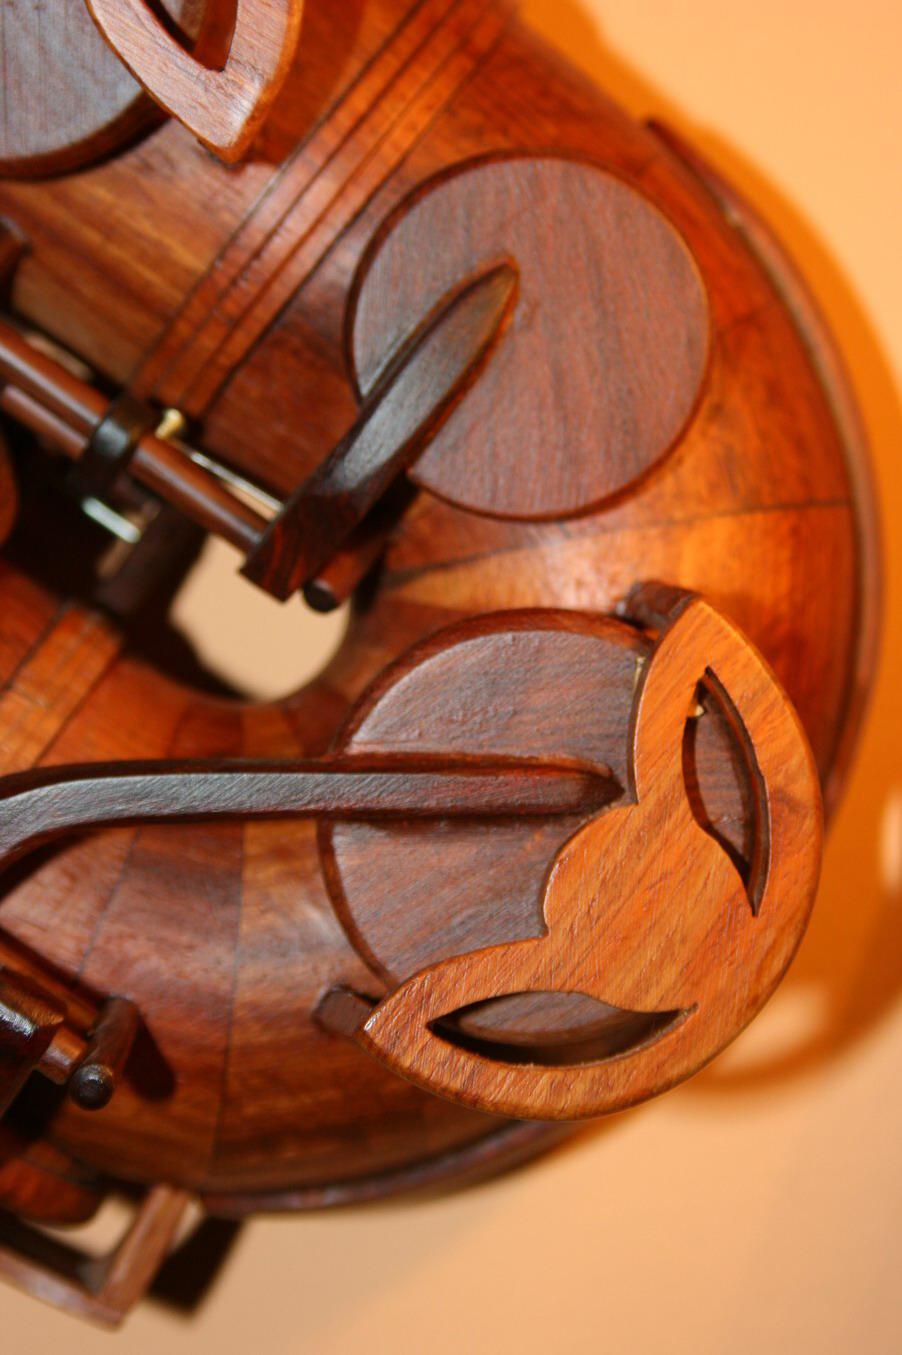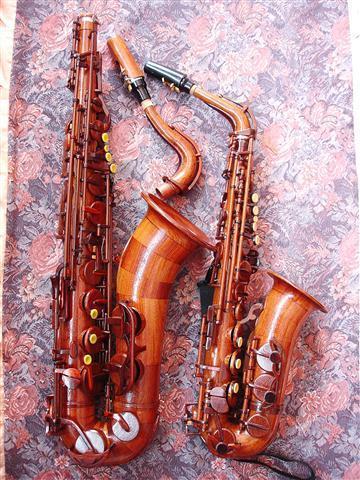The first image is the image on the left, the second image is the image on the right. Given the left and right images, does the statement "The entire length of one saxophone is shown in each image." hold true? Answer yes or no. No. The first image is the image on the left, the second image is the image on the right. Considering the images on both sides, is "Each image shows a single upright instrument on a plain background." valid? Answer yes or no. No. 